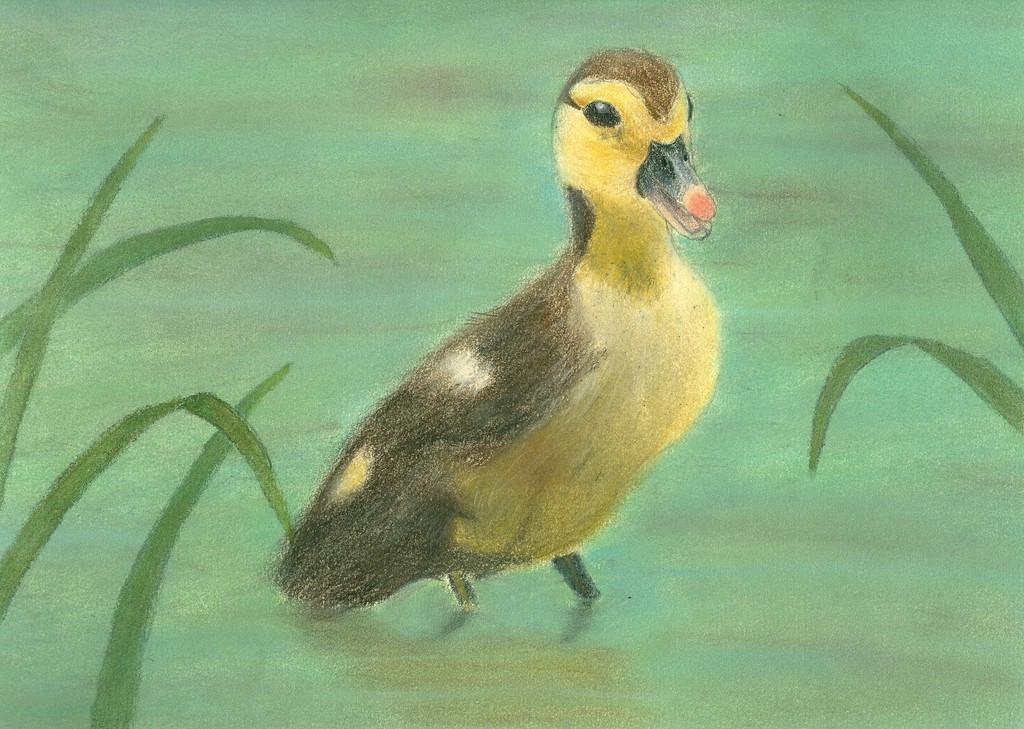What is the main subject of the painting in the image? The painting depicts a bird. Are there any other elements in the painting besides the bird? Yes, the painting also includes leaves. How many clouds are visible in the painting? There are no clouds visible in the painting, as it only depicts a bird and leaves. 